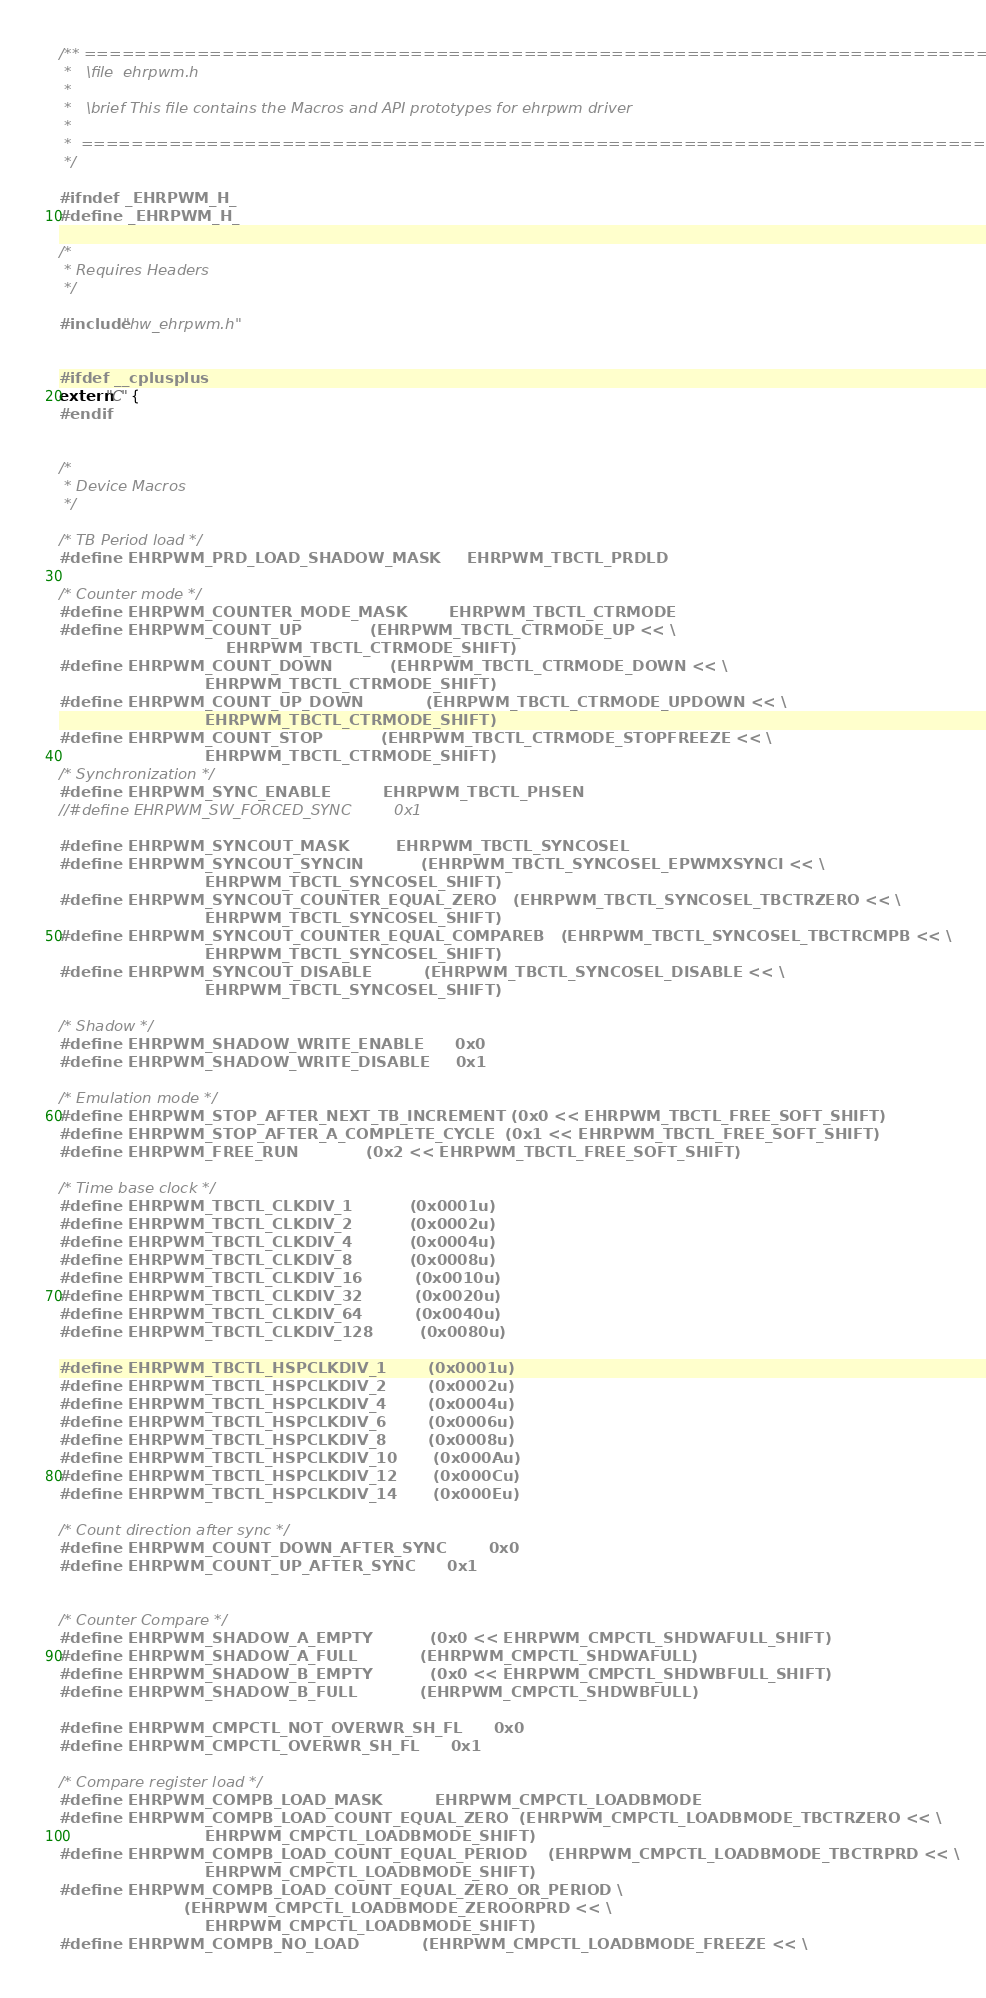Convert code to text. <code><loc_0><loc_0><loc_500><loc_500><_C_>/** ============================================================================
 *   \file  ehrpwm.h
 *
 *   \brief This file contains the Macros and API prototypes for ehrpwm driver
 *
 *  ============================================================================
 */

#ifndef _EHRPWM_H_
#define _EHRPWM_H_

/* 
 * Requires Headers 
 */
 
#include "hw_ehrpwm.h"


#ifdef __cplusplus
extern "C" {
#endif


/*
 * Device Macros
 */

/* TB Period load */
#define EHRPWM_PRD_LOAD_SHADOW_MASK     EHRPWM_TBCTL_PRDLD

/* Counter mode */
#define EHRPWM_COUNTER_MODE_MASK        EHRPWM_TBCTL_CTRMODE 
#define EHRPWM_COUNT_UP             (EHRPWM_TBCTL_CTRMODE_UP << \
                                EHRPWM_TBCTL_CTRMODE_SHIFT)
#define EHRPWM_COUNT_DOWN           (EHRPWM_TBCTL_CTRMODE_DOWN << \
                            EHRPWM_TBCTL_CTRMODE_SHIFT)
#define EHRPWM_COUNT_UP_DOWN            (EHRPWM_TBCTL_CTRMODE_UPDOWN << \
                            EHRPWM_TBCTL_CTRMODE_SHIFT)
#define EHRPWM_COUNT_STOP           (EHRPWM_TBCTL_CTRMODE_STOPFREEZE << \
                            EHRPWM_TBCTL_CTRMODE_SHIFT)
/* Synchronization */
#define EHRPWM_SYNC_ENABLE          EHRPWM_TBCTL_PHSEN
//#define EHRPWM_SW_FORCED_SYNC         0x1

#define EHRPWM_SYNCOUT_MASK         EHRPWM_TBCTL_SYNCOSEL   
#define EHRPWM_SYNCOUT_SYNCIN           (EHRPWM_TBCTL_SYNCOSEL_EPWMXSYNCI << \
                            EHRPWM_TBCTL_SYNCOSEL_SHIFT)
#define EHRPWM_SYNCOUT_COUNTER_EQUAL_ZERO   (EHRPWM_TBCTL_SYNCOSEL_TBCTRZERO << \
                            EHRPWM_TBCTL_SYNCOSEL_SHIFT)
#define EHRPWM_SYNCOUT_COUNTER_EQUAL_COMPAREB   (EHRPWM_TBCTL_SYNCOSEL_TBCTRCMPB << \
                            EHRPWM_TBCTL_SYNCOSEL_SHIFT)
#define EHRPWM_SYNCOUT_DISABLE          (EHRPWM_TBCTL_SYNCOSEL_DISABLE << \
                            EHRPWM_TBCTL_SYNCOSEL_SHIFT)

/* Shadow */
#define EHRPWM_SHADOW_WRITE_ENABLE      0x0
#define EHRPWM_SHADOW_WRITE_DISABLE     0x1

/* Emulation mode */
#define EHRPWM_STOP_AFTER_NEXT_TB_INCREMENT (0x0 << EHRPWM_TBCTL_FREE_SOFT_SHIFT)
#define EHRPWM_STOP_AFTER_A_COMPLETE_CYCLE  (0x1 << EHRPWM_TBCTL_FREE_SOFT_SHIFT)
#define EHRPWM_FREE_RUN             (0x2 << EHRPWM_TBCTL_FREE_SOFT_SHIFT)

/* Time base clock */
#define EHRPWM_TBCTL_CLKDIV_1           (0x0001u)
#define EHRPWM_TBCTL_CLKDIV_2           (0x0002u)
#define EHRPWM_TBCTL_CLKDIV_4           (0x0004u)
#define EHRPWM_TBCTL_CLKDIV_8           (0x0008u)
#define EHRPWM_TBCTL_CLKDIV_16          (0x0010u)
#define EHRPWM_TBCTL_CLKDIV_32          (0x0020u)
#define EHRPWM_TBCTL_CLKDIV_64          (0x0040u)
#define EHRPWM_TBCTL_CLKDIV_128         (0x0080u)

#define EHRPWM_TBCTL_HSPCLKDIV_1        (0x0001u)
#define EHRPWM_TBCTL_HSPCLKDIV_2        (0x0002u)
#define EHRPWM_TBCTL_HSPCLKDIV_4        (0x0004u)
#define EHRPWM_TBCTL_HSPCLKDIV_6        (0x0006u)
#define EHRPWM_TBCTL_HSPCLKDIV_8        (0x0008u)
#define EHRPWM_TBCTL_HSPCLKDIV_10       (0x000Au)
#define EHRPWM_TBCTL_HSPCLKDIV_12       (0x000Cu)
#define EHRPWM_TBCTL_HSPCLKDIV_14       (0x000Eu)

/* Count direction after sync */
#define EHRPWM_COUNT_DOWN_AFTER_SYNC        0x0
#define EHRPWM_COUNT_UP_AFTER_SYNC      0x1


/* Counter Compare */
#define EHRPWM_SHADOW_A_EMPTY           (0x0 << EHRPWM_CMPCTL_SHDWAFULL_SHIFT)
#define EHRPWM_SHADOW_A_FULL            (EHRPWM_CMPCTL_SHDWAFULL)
#define EHRPWM_SHADOW_B_EMPTY           (0x0 << EHRPWM_CMPCTL_SHDWBFULL_SHIFT)
#define EHRPWM_SHADOW_B_FULL            (EHRPWM_CMPCTL_SHDWBFULL)

#define EHRPWM_CMPCTL_NOT_OVERWR_SH_FL      0x0
#define EHRPWM_CMPCTL_OVERWR_SH_FL      0x1

/* Compare register load */
#define EHRPWM_COMPB_LOAD_MASK          EHRPWM_CMPCTL_LOADBMODE
#define EHRPWM_COMPB_LOAD_COUNT_EQUAL_ZERO  (EHRPWM_CMPCTL_LOADBMODE_TBCTRZERO << \
                            EHRPWM_CMPCTL_LOADBMODE_SHIFT)
#define EHRPWM_COMPB_LOAD_COUNT_EQUAL_PERIOD    (EHRPWM_CMPCTL_LOADBMODE_TBCTRPRD << \
                            EHRPWM_CMPCTL_LOADBMODE_SHIFT)
#define EHRPWM_COMPB_LOAD_COUNT_EQUAL_ZERO_OR_PERIOD \
                        (EHRPWM_CMPCTL_LOADBMODE_ZEROORPRD << \
                            EHRPWM_CMPCTL_LOADBMODE_SHIFT)
#define EHRPWM_COMPB_NO_LOAD            (EHRPWM_CMPCTL_LOADBMODE_FREEZE << \</code> 